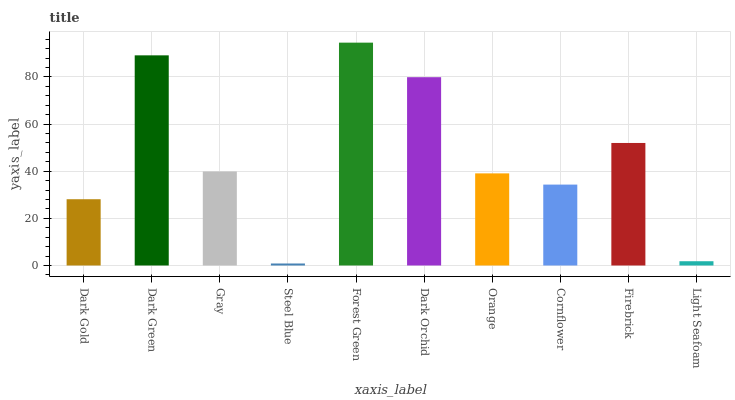Is Dark Green the minimum?
Answer yes or no. No. Is Dark Green the maximum?
Answer yes or no. No. Is Dark Green greater than Dark Gold?
Answer yes or no. Yes. Is Dark Gold less than Dark Green?
Answer yes or no. Yes. Is Dark Gold greater than Dark Green?
Answer yes or no. No. Is Dark Green less than Dark Gold?
Answer yes or no. No. Is Gray the high median?
Answer yes or no. Yes. Is Orange the low median?
Answer yes or no. Yes. Is Orange the high median?
Answer yes or no. No. Is Firebrick the low median?
Answer yes or no. No. 